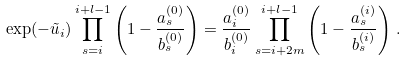<formula> <loc_0><loc_0><loc_500><loc_500>\exp ( - \tilde { u } _ { i } ) \prod _ { s = i } ^ { i + l - 1 } \left ( 1 - \frac { a _ { s } ^ { ( 0 ) } } { b _ { s } ^ { ( 0 ) } } \right ) = \frac { a _ { i } ^ { ( 0 ) } } { b _ { i } ^ { ( 0 ) } } \prod _ { s = i + 2 m } ^ { i + l - 1 } \left ( 1 - \frac { a _ { s } ^ { ( i ) } } { b _ { s } ^ { ( i ) } } \right ) \, .</formula> 